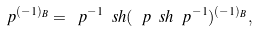Convert formula to latex. <formula><loc_0><loc_0><loc_500><loc_500>\ p ^ { ( - 1 ) _ { B } } = \ p ^ { - 1 } \ s h ( \ p \ s h \ p ^ { - 1 } ) ^ { ( - 1 ) _ { B } } ,</formula> 